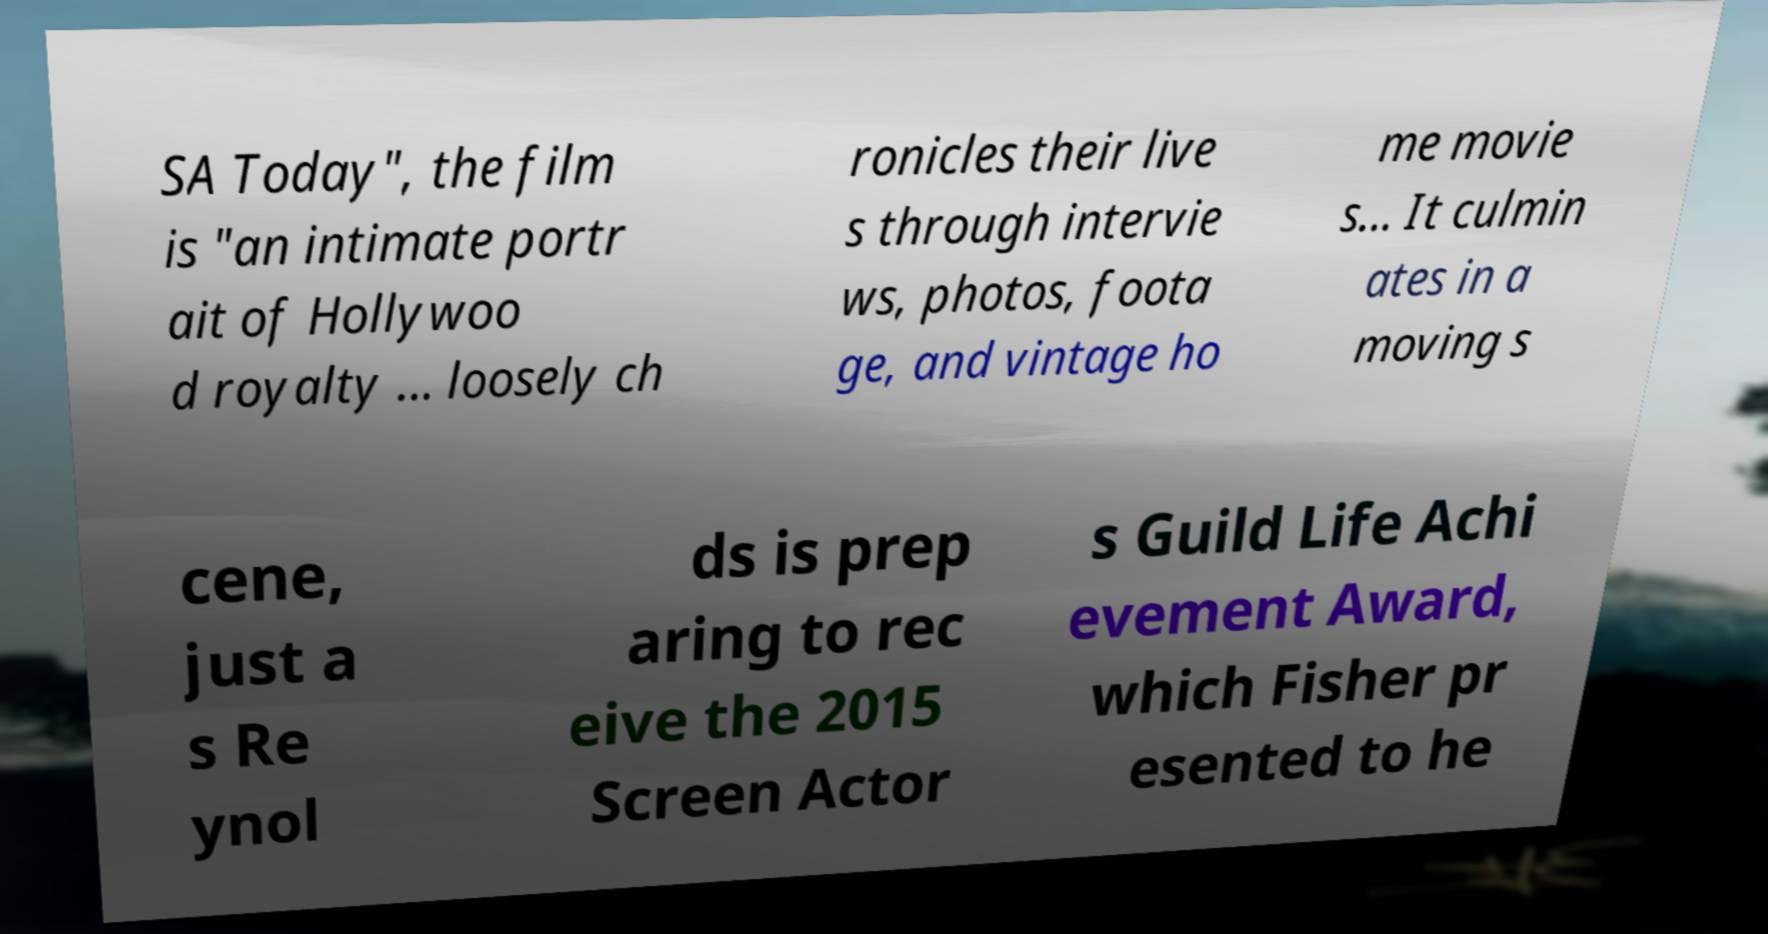What messages or text are displayed in this image? I need them in a readable, typed format. SA Today", the film is "an intimate portr ait of Hollywoo d royalty ... loosely ch ronicles their live s through intervie ws, photos, foota ge, and vintage ho me movie s... It culmin ates in a moving s cene, just a s Re ynol ds is prep aring to rec eive the 2015 Screen Actor s Guild Life Achi evement Award, which Fisher pr esented to he 